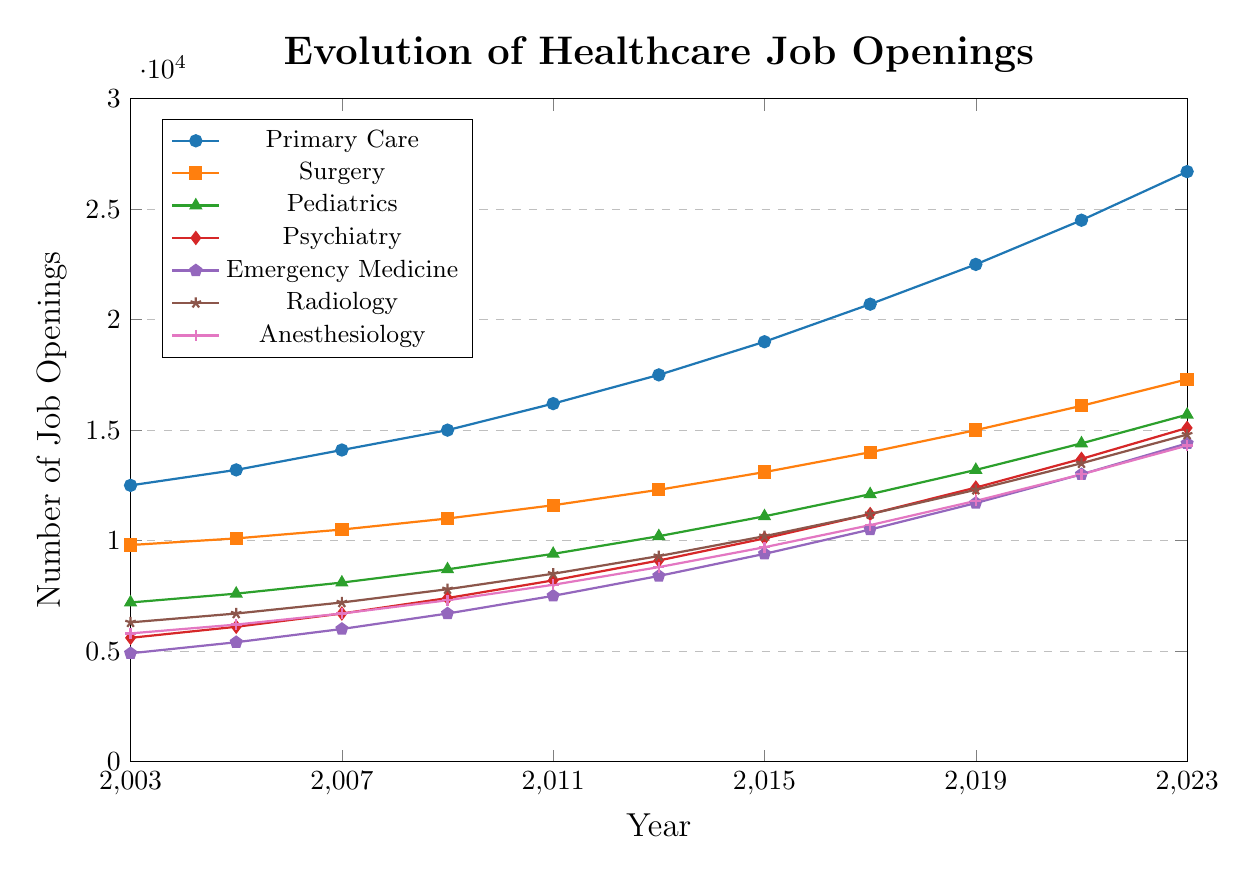What is the overall trend of job openings in Primary Care over the 20 years? By observing the line for Primary Care, we can see it starts from 12,500 in 2003 and ends at 26,700 in 2023, showing a consistent upward trend.
Answer: Upward trend How do job openings in Psychiatry in 2023 compare to those in Pediatrics in 2013? In 2023, Psychiatry shows 15,100 job openings and in 2013, Pediatrics has 10,200 job openings. 15,100 is greater than 10,200.
Answer: Psychiatry in 2023 is higher Which specialty had the least number of job openings in 2003 and what was the number? By comparing the starting points of each line, Emergency Medicine in 2003 had the least with 4,900.
Answer: Emergency Medicine, 4,900 By how much did job openings in Surgery increase from 2011 to 2015? Surgery had 11,600 job openings in 2011 and 13,100 in 2015. The increase is 13,100 - 11,600 = 1,500.
Answer: 1,500 Which specialty has the fastest growing job market when considering the slope of the lines over 20 years? Primary Care shows the steepest upward slope as it increased from 12,500 in 2003 to 26,700 in 2023, indicating the fastest growth.
Answer: Primary Care Are the job openings for Radiology in 2023 more than double those in 2003? Radiology in 2003 had 6,300 openings; double of that is 12,600. In 2023, Radiology has 14,800 openings, which is more than double.
Answer: Yes What is the difference in job openings between Anesthesiology and Pediatrics in 2019? Anesthesiology had 11,800 job openings and Pediatrics had 13,200 in 2019. The difference is 13,200 - 11,800 = 1,400.
Answer: 1,400 Which specialty had the smallest rate of increase in job openings between 2003 and 2023? Comparing the slopes of all lines, Anesthesiology had the smallest increase from 5,800 to 14,300, which is a smaller increase than other lines.
Answer: Anesthesiology By what percentage did job openings in Emergency Medicine increase from 2003 to 2023? In 2003, Emergency Medicine had 4,900 openings and in 2023, it had 14,400. The percentage increase is ((14,400 - 4,900) / 4,900) * 100 ≈ 193.88%.
Answer: ~193.88% 